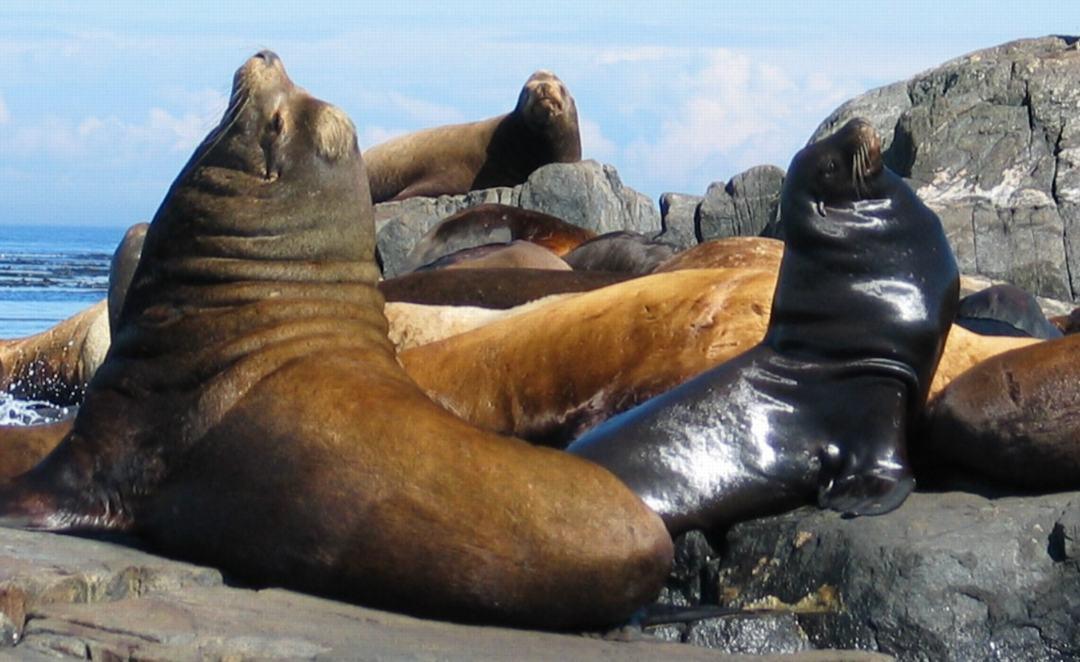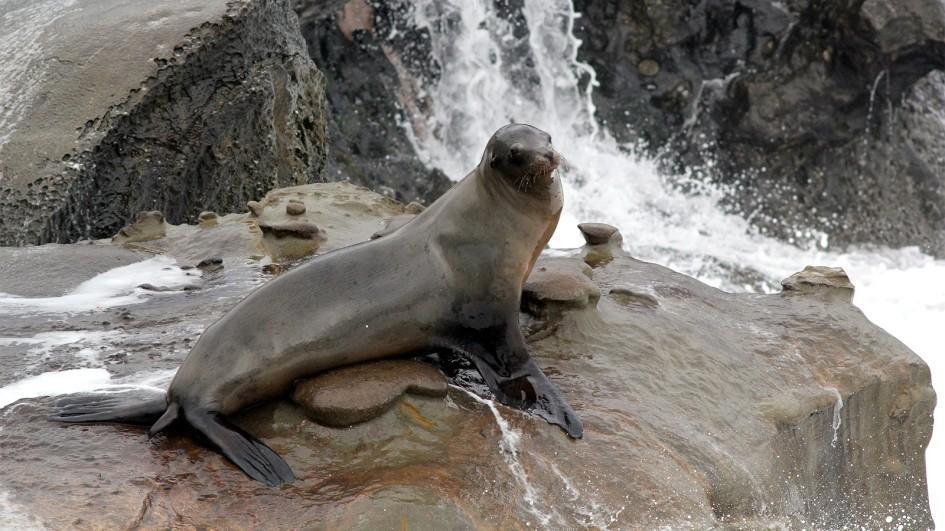The first image is the image on the left, the second image is the image on the right. Evaluate the accuracy of this statement regarding the images: "One or more seals are sitting on a rock in both images.". Is it true? Answer yes or no. Yes. 